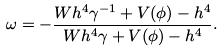<formula> <loc_0><loc_0><loc_500><loc_500>\omega = - \frac { W h ^ { 4 } \gamma ^ { - 1 } + V ( \phi ) - h ^ { 4 } } { W h ^ { 4 } \gamma + V ( \phi ) - h ^ { 4 } } .</formula> 